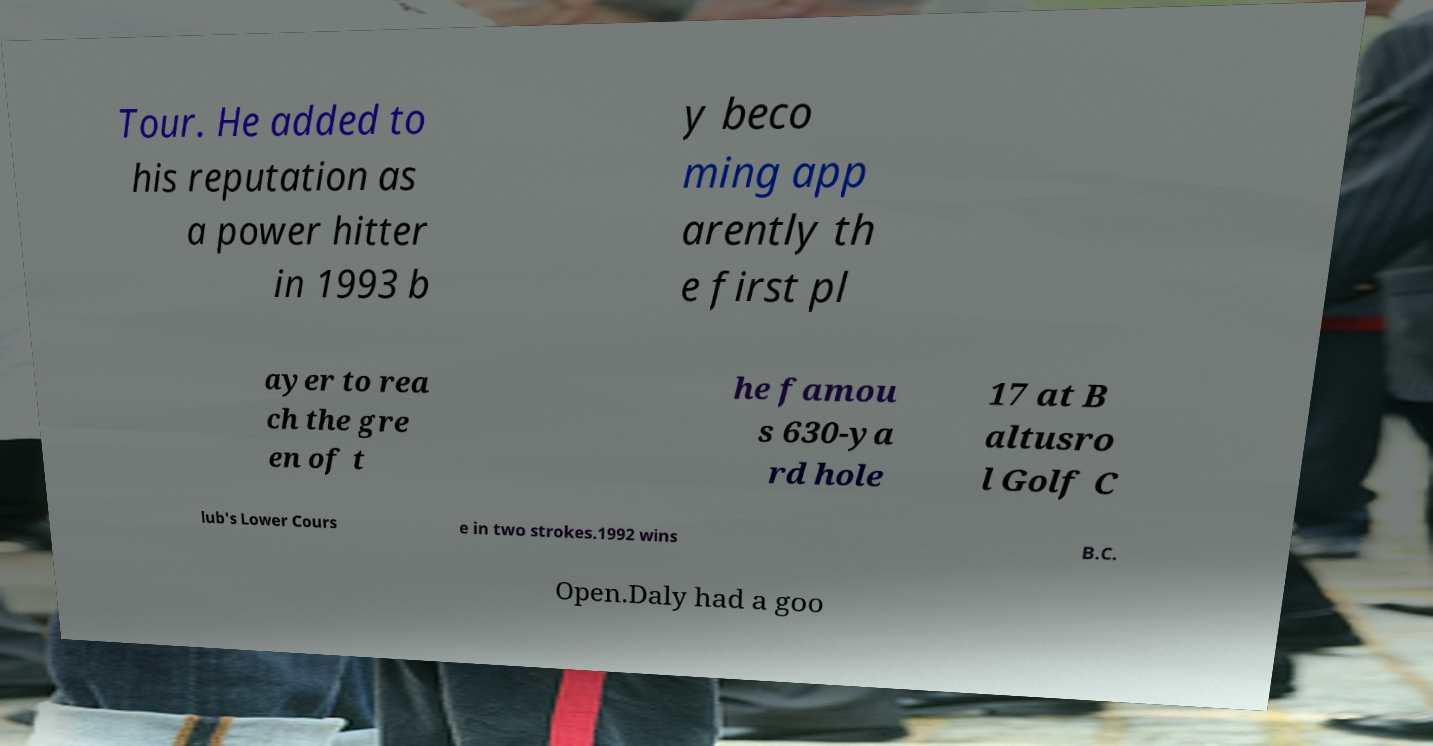Could you assist in decoding the text presented in this image and type it out clearly? Tour. He added to his reputation as a power hitter in 1993 b y beco ming app arently th e first pl ayer to rea ch the gre en of t he famou s 630-ya rd hole 17 at B altusro l Golf C lub's Lower Cours e in two strokes.1992 wins B.C. Open.Daly had a goo 